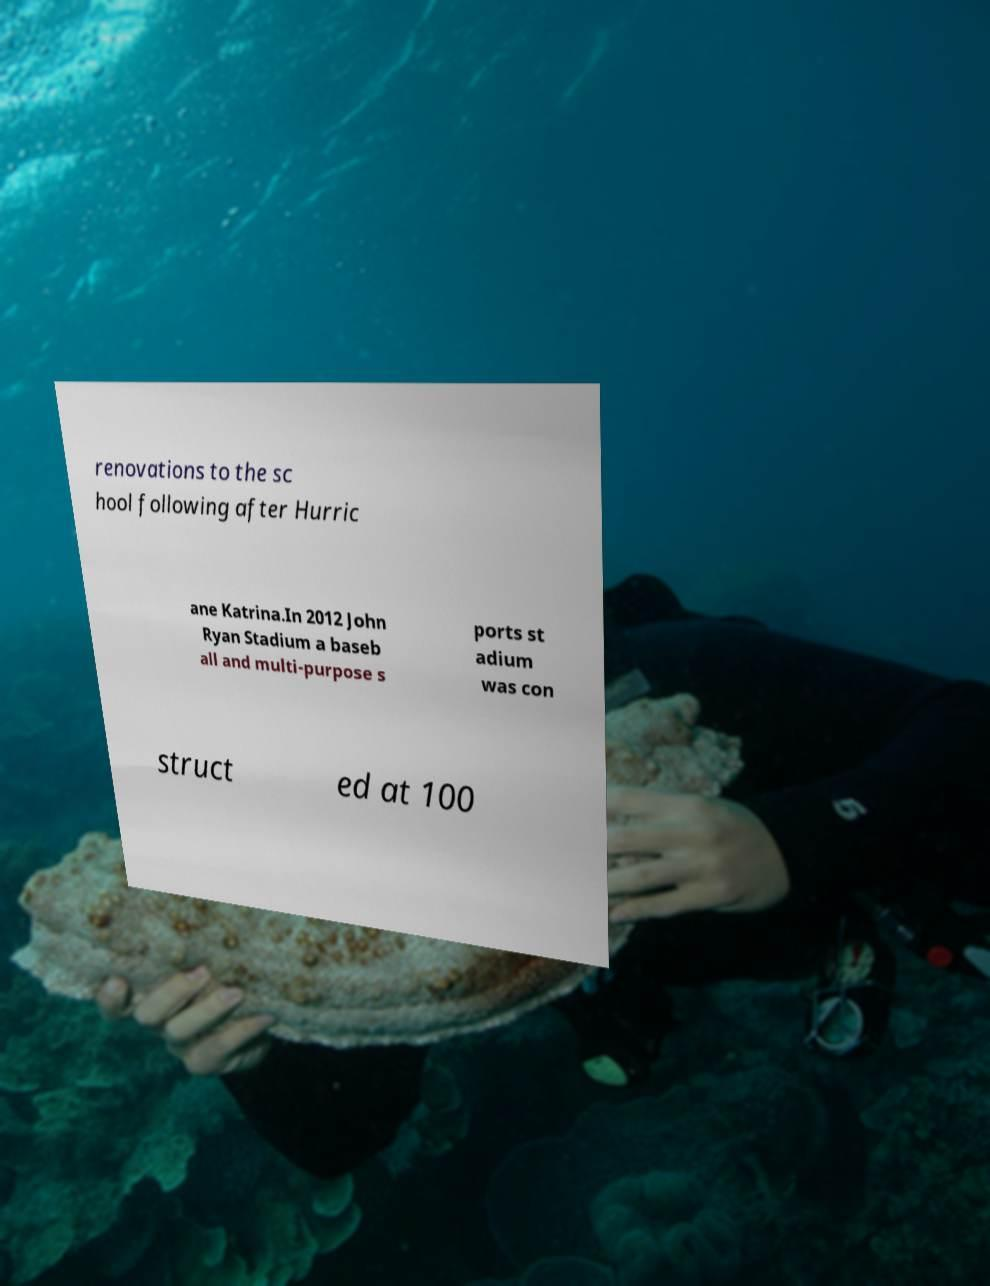Could you extract and type out the text from this image? renovations to the sc hool following after Hurric ane Katrina.In 2012 John Ryan Stadium a baseb all and multi-purpose s ports st adium was con struct ed at 100 